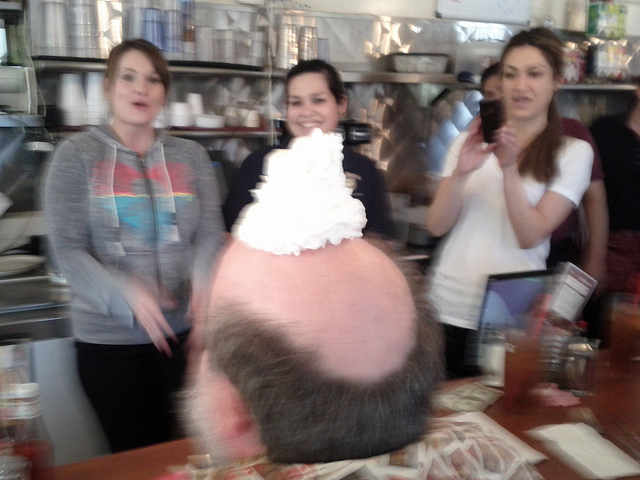How are the people in the image likely related to each other? The individuals in the photograph appear to be sharing a joyful moment in a casual dining setting, which could suggest they are friends or family enjoying a meal together. Their relaxed demeanors and broad smiles indicate familiarity and ease around each other, typical of close relationships. 